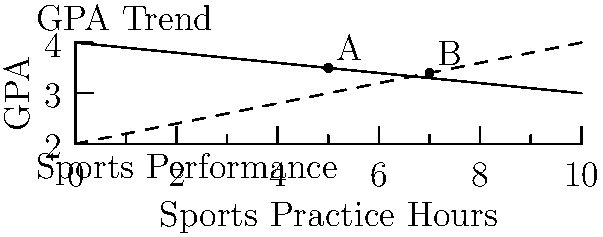The graph shows the relationship between a student's GPA and sports practice hours. The solid line represents the GPA trend, and the dashed line represents sports performance. Points A and B represent two different scenarios. What conclusion can be drawn about the student's academic performance and sports commitment based on the movement from point A to point B? To answer this question, let's analyze the graph step by step:

1. Interpret the axes:
   - X-axis: Sports Practice Hours
   - Y-axis: GPA

2. Understand the lines:
   - Solid line: GPA Trend (decreasing as practice hours increase)
   - Dashed line: Sports Performance (increasing as practice hours increase)

3. Locate points A and B:
   - Point A: (5, 3.5)
   - Point B: (7, 3.4)

4. Analyze the movement from A to B:
   - X-coordinate increases from 5 to 7, meaning sports practice hours increased by 2
   - Y-coordinate decreases slightly from 3.5 to 3.4, indicating a small drop in GPA

5. Interpret the changes:
   - Increased sports practice hours (from 5 to 7)
   - Slight decrease in GPA (from 3.5 to 3.4)
   - Improved sports performance (as indicated by the upward slope of the dashed line)

6. Draw a conclusion:
   The student has increased their sports commitment (more practice hours) which has led to improved sports performance. However, this has come at the cost of a slight decrease in academic performance (lower GPA).
Answer: Increased sports commitment slightly decreased academic performance but improved sports performance. 